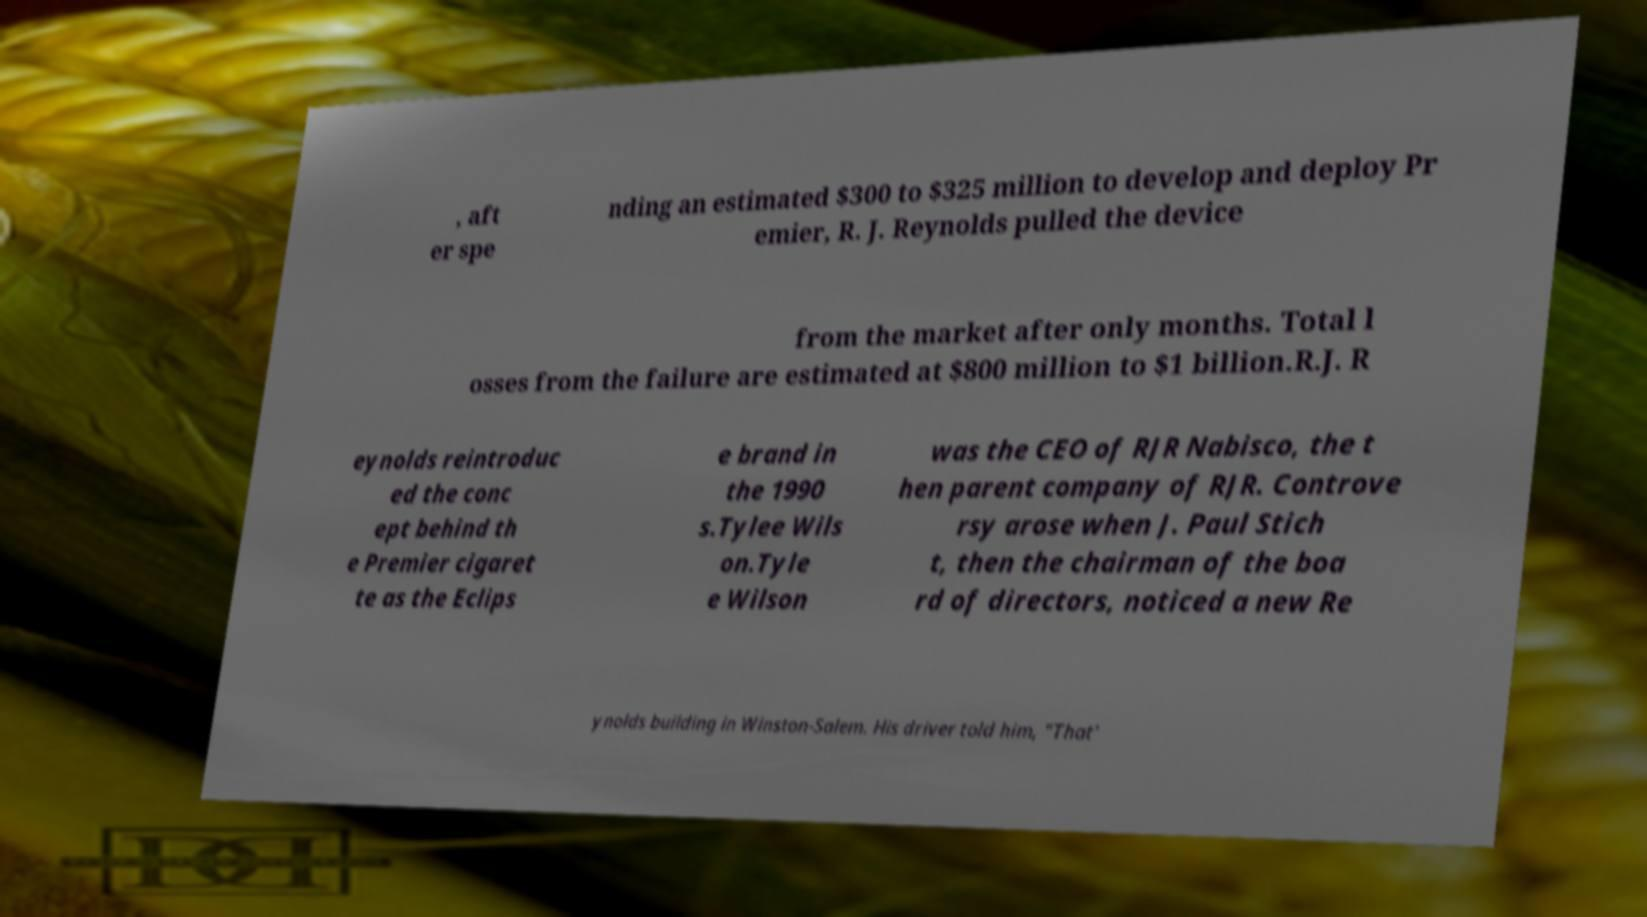Please read and relay the text visible in this image. What does it say? , aft er spe nding an estimated $300 to $325 million to develop and deploy Pr emier, R. J. Reynolds pulled the device from the market after only months. Total l osses from the failure are estimated at $800 million to $1 billion.R.J. R eynolds reintroduc ed the conc ept behind th e Premier cigaret te as the Eclips e brand in the 1990 s.Tylee Wils on.Tyle e Wilson was the CEO of RJR Nabisco, the t hen parent company of RJR. Controve rsy arose when J. Paul Stich t, then the chairman of the boa rd of directors, noticed a new Re ynolds building in Winston-Salem. His driver told him, "That' 